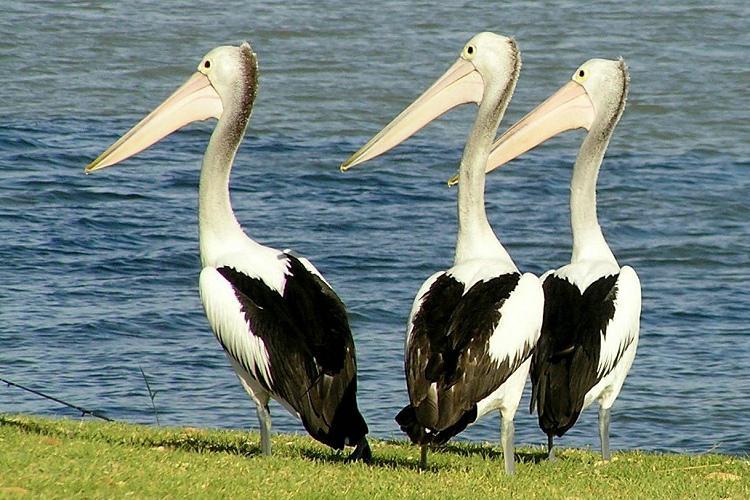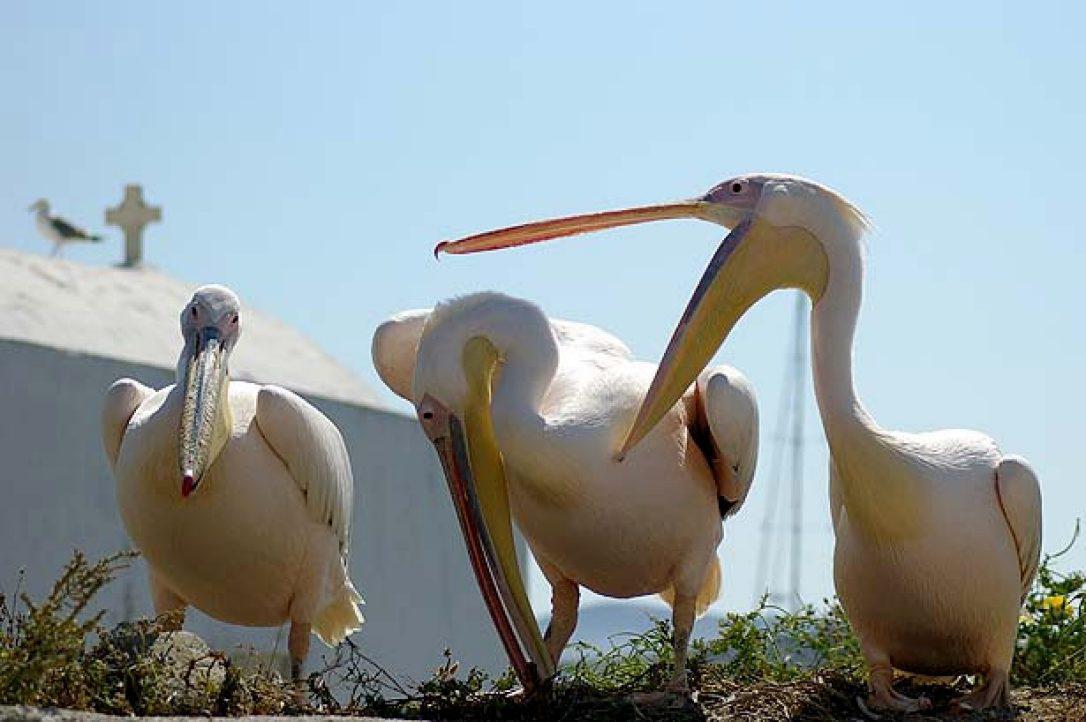The first image is the image on the left, the second image is the image on the right. For the images displayed, is the sentence "At least 6 pelicans face left." factually correct? Answer yes or no. No. The first image is the image on the left, the second image is the image on the right. Assess this claim about the two images: "In one of the image there is a pelican in the water.". Correct or not? Answer yes or no. No. 